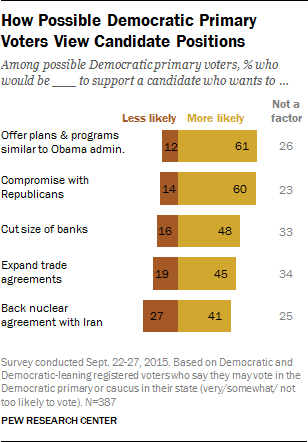Highlight a few significant elements in this photo. Expanding trade agreements is less likely to reduce the size of banks than cutting their size, according to the data. Democratic voters believe that the possibility of a nuclear agreement with Iran is less likely than their support for it. 